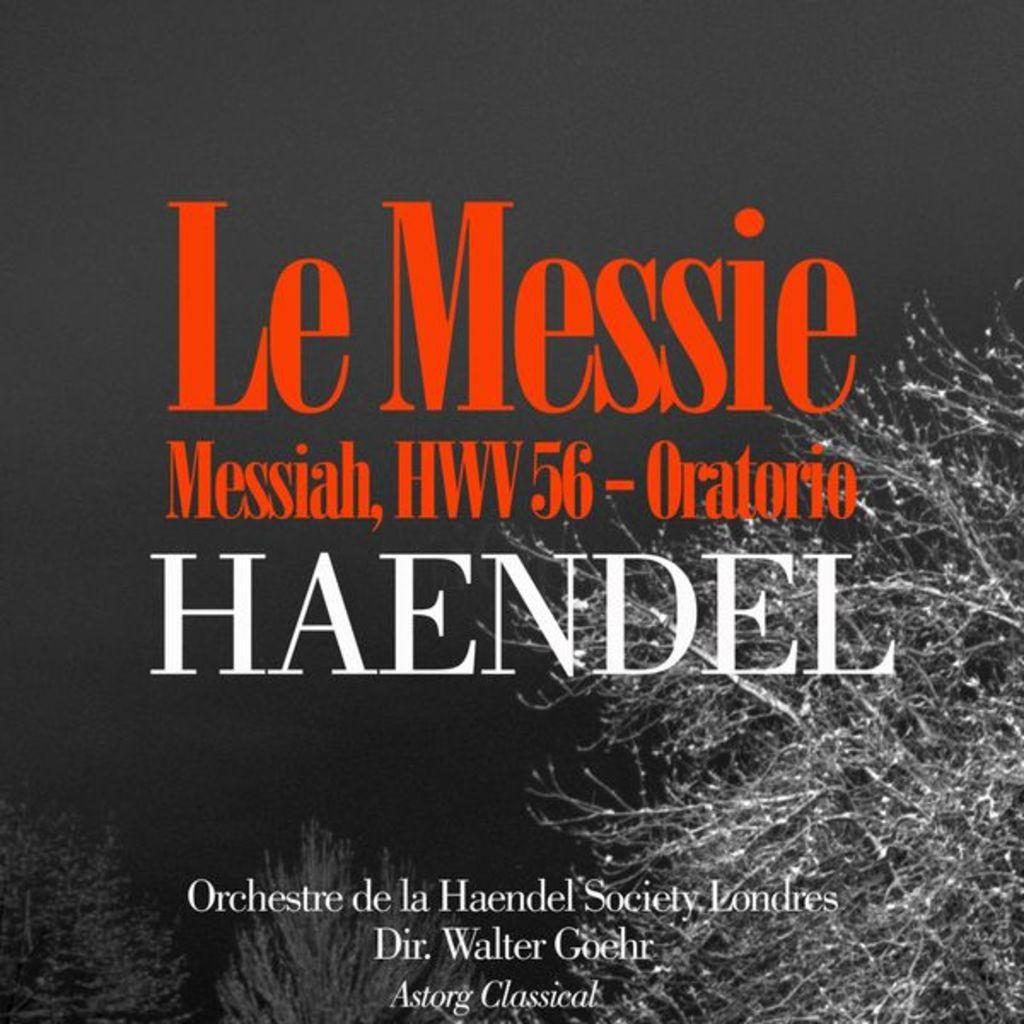Who is the director?
Provide a succinct answer. Walter goehr. Which brand?
Your answer should be compact. Unanswerable. 